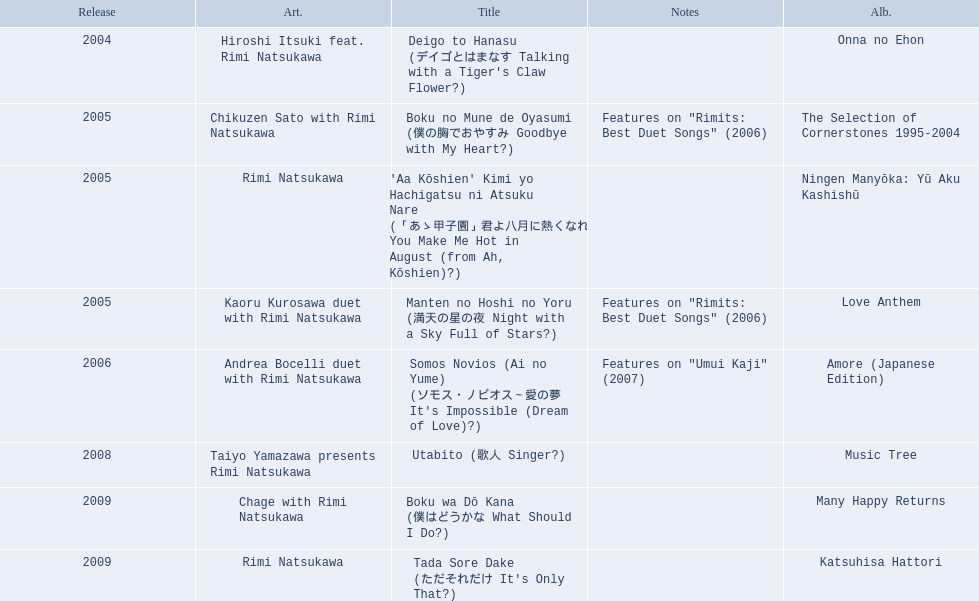What year was onna no ehon released? 2004. What year was music tree released? 2008. Which of the two was not released in 2004? Music Tree. 